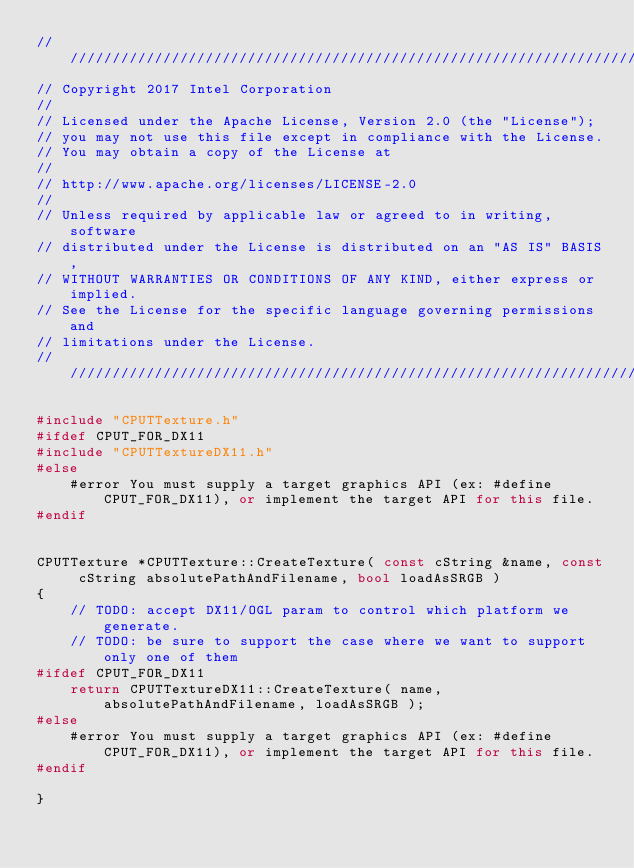Convert code to text. <code><loc_0><loc_0><loc_500><loc_500><_C++_>/////////////////////////////////////////////////////////////////////////////////////////////
// Copyright 2017 Intel Corporation
//
// Licensed under the Apache License, Version 2.0 (the "License");
// you may not use this file except in compliance with the License.
// You may obtain a copy of the License at
//
// http://www.apache.org/licenses/LICENSE-2.0
//
// Unless required by applicable law or agreed to in writing, software
// distributed under the License is distributed on an "AS IS" BASIS,
// WITHOUT WARRANTIES OR CONDITIONS OF ANY KIND, either express or implied.
// See the License for the specific language governing permissions and
// limitations under the License.
/////////////////////////////////////////////////////////////////////////////////////////////

#include "CPUTTexture.h"
#ifdef CPUT_FOR_DX11
#include "CPUTTextureDX11.h"
#else    
    #error You must supply a target graphics API (ex: #define CPUT_FOR_DX11), or implement the target API for this file.
#endif


CPUTTexture *CPUTTexture::CreateTexture( const cString &name, const cString absolutePathAndFilename, bool loadAsSRGB )
{
    // TODO: accept DX11/OGL param to control which platform we generate.
    // TODO: be sure to support the case where we want to support only one of them
#ifdef CPUT_FOR_DX11
    return CPUTTextureDX11::CreateTexture( name, absolutePathAndFilename, loadAsSRGB );
#else    
    #error You must supply a target graphics API (ex: #define CPUT_FOR_DX11), or implement the target API for this file.
#endif
    
}
</code> 